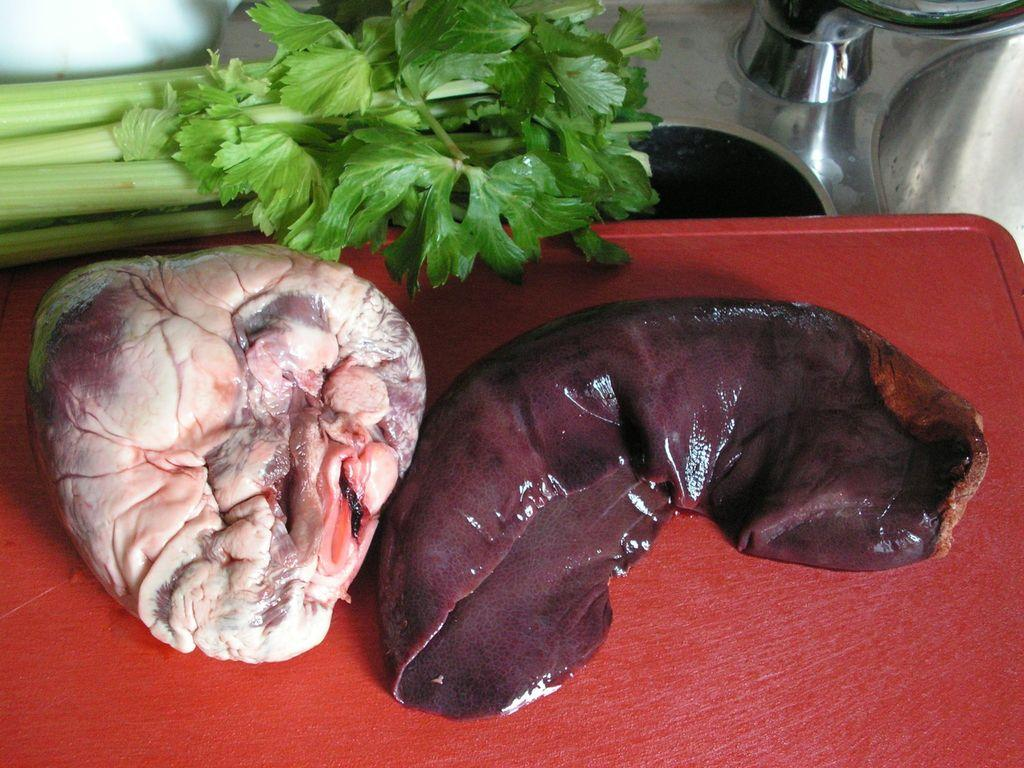What color is the chopping board in the image? The chopping board in the image is red. What is on the chopping board? There are meat pieces on the chopping board. What type of vegetables can be seen in the image? There are green vegetables in the image. How many women are sitting on the cushion in the image? There are no women or cushions present in the image. 